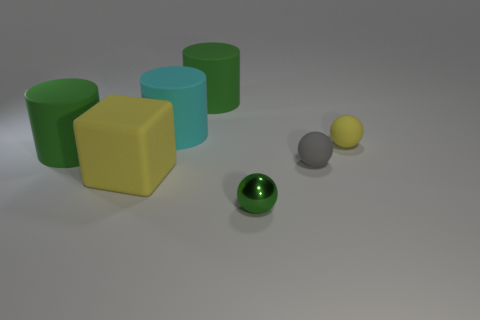Do the sphere that is on the right side of the tiny gray matte thing and the green matte cylinder in front of the large cyan cylinder have the same size?
Keep it short and to the point. No. How many gray objects are small rubber spheres or large cubes?
Offer a very short reply. 1. There is a ball that is the same color as the matte block; what size is it?
Offer a terse response. Small. Are there more small matte objects than tiny green shiny objects?
Provide a succinct answer. Yes. Does the small metallic sphere have the same color as the big block?
Keep it short and to the point. No. What number of objects are either big rubber cylinders or green matte objects behind the small yellow thing?
Your answer should be very brief. 3. What number of other objects are there of the same shape as the metal object?
Your answer should be very brief. 2. Are there fewer matte cylinders behind the small yellow matte thing than tiny green shiny things to the left of the green shiny object?
Offer a very short reply. No. Is there anything else that has the same material as the cyan object?
Keep it short and to the point. Yes. The tiny yellow object that is made of the same material as the yellow block is what shape?
Provide a short and direct response. Sphere. 